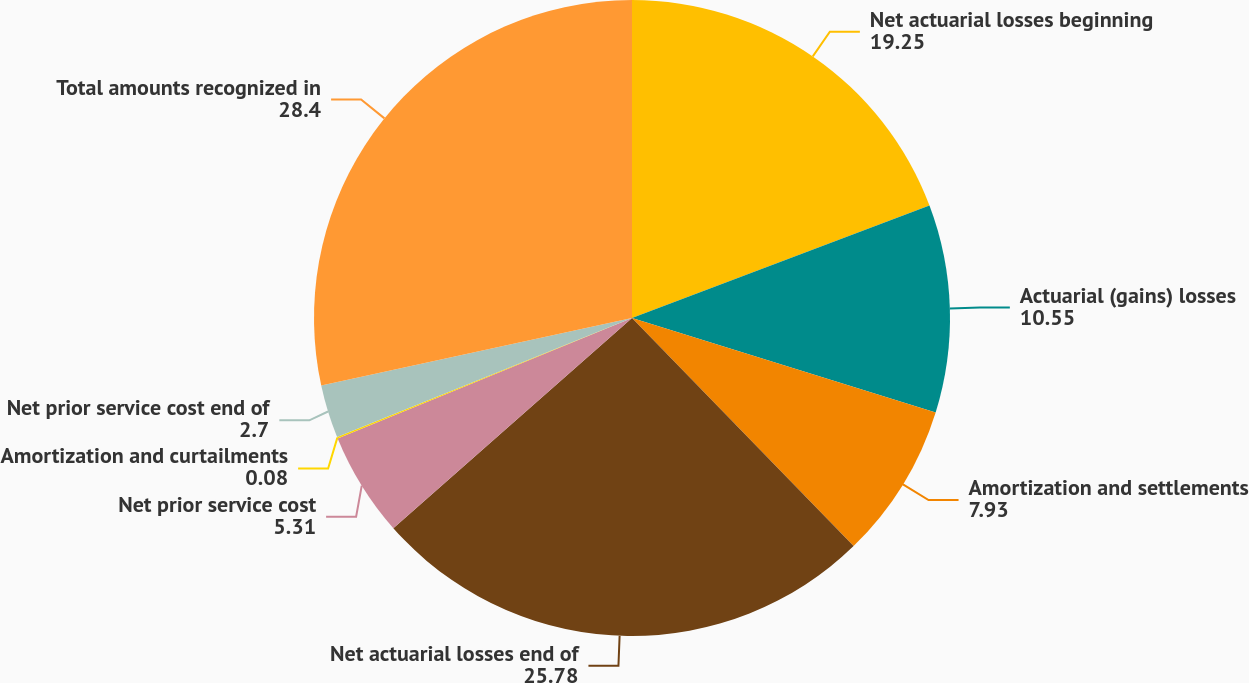<chart> <loc_0><loc_0><loc_500><loc_500><pie_chart><fcel>Net actuarial losses beginning<fcel>Actuarial (gains) losses<fcel>Amortization and settlements<fcel>Net actuarial losses end of<fcel>Net prior service cost<fcel>Amortization and curtailments<fcel>Net prior service cost end of<fcel>Total amounts recognized in<nl><fcel>19.25%<fcel>10.55%<fcel>7.93%<fcel>25.78%<fcel>5.31%<fcel>0.08%<fcel>2.7%<fcel>28.4%<nl></chart> 